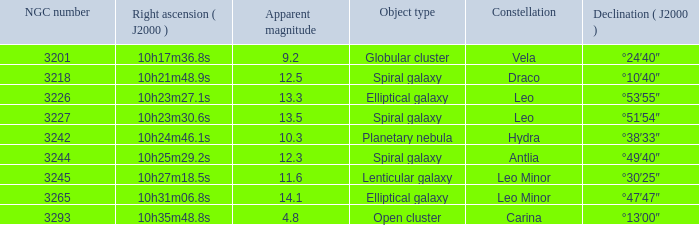What is the total of Apparent magnitudes for an NGC number larger than 3293? None. 